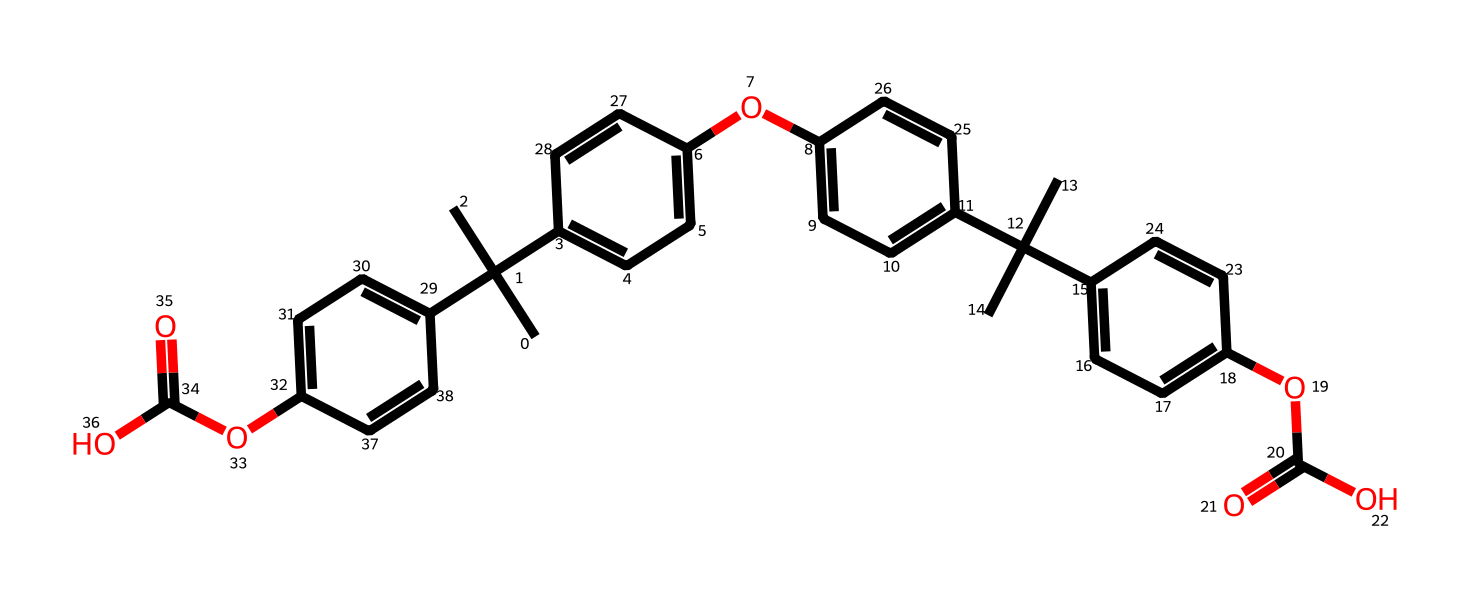What is the molecular formula for this compound? To find the molecular formula, we need to count the number of each type of atom in the SMILES representation. The provided SMILES indicates there are carbon (C), hydrogen (H), and oxygen (O) atoms. Upon counting, we find 35 carbons, 44 hydrogens, and 4 oxygens, which gives us the molecular formula C35H44O4.
Answer: C35H44O4 How many hydroxyl (-OH) groups are present in this structure? Hydroxyl groups are indicated by the –OH notation. By examining the structure in the SMILES, I can identify two instances where hydroxyl groups are present attached to the carbon rings.
Answer: 2 What type of chemical is this compound classified as? This compound contains an aromatic ring with hydroxyl groups, characteristic of phenolic compounds. The presence of these functional groups and their aromatic nature confirm that it is a phenol.
Answer: phenol What is the significance of the methoxy (-OCH3) groups in this structure? The methoxy groups are indicated by the presence of –O–C in the structure, which in phenolic compounds typically implies increased solubility and stability. They also affect the light absorption properties, which is relevant in blue light-filtering applications.
Answer: increased solubility How many benzene rings are in the chemical structure? Benzene rings can be identified by the presence of alternating double bonds and enclosed carbon structures in the SMILES notation. Counting the distinct phenolic moieties in the structure, I can see there are 4 benzene rings present.
Answer: 4 What is the role of the carboxylic acid (-COOH) groups in the structure? Carboxylic acid groups provide acidic characteristics and can participate in hydrogen bonding. These properties can enhance the interaction of the phenolic compound with light, which is important for filtering blue light in glasses.
Answer: acid characteristics 